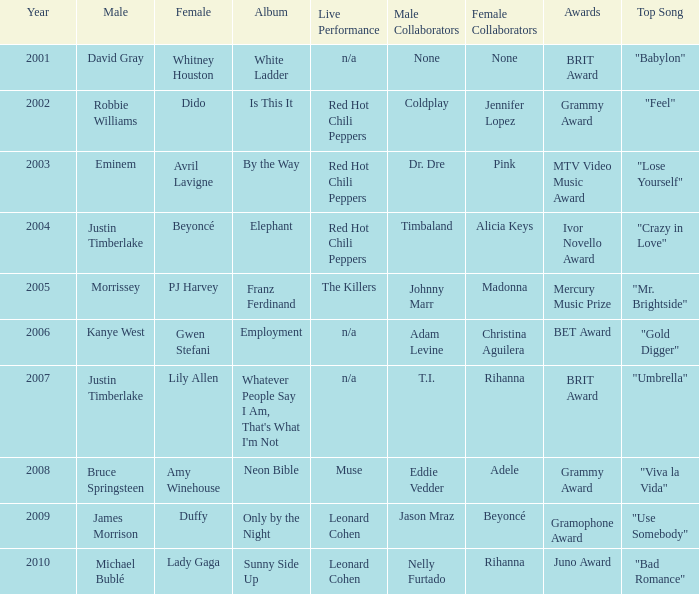Who is the male partner for amy winehouse? Bruce Springsteen. 